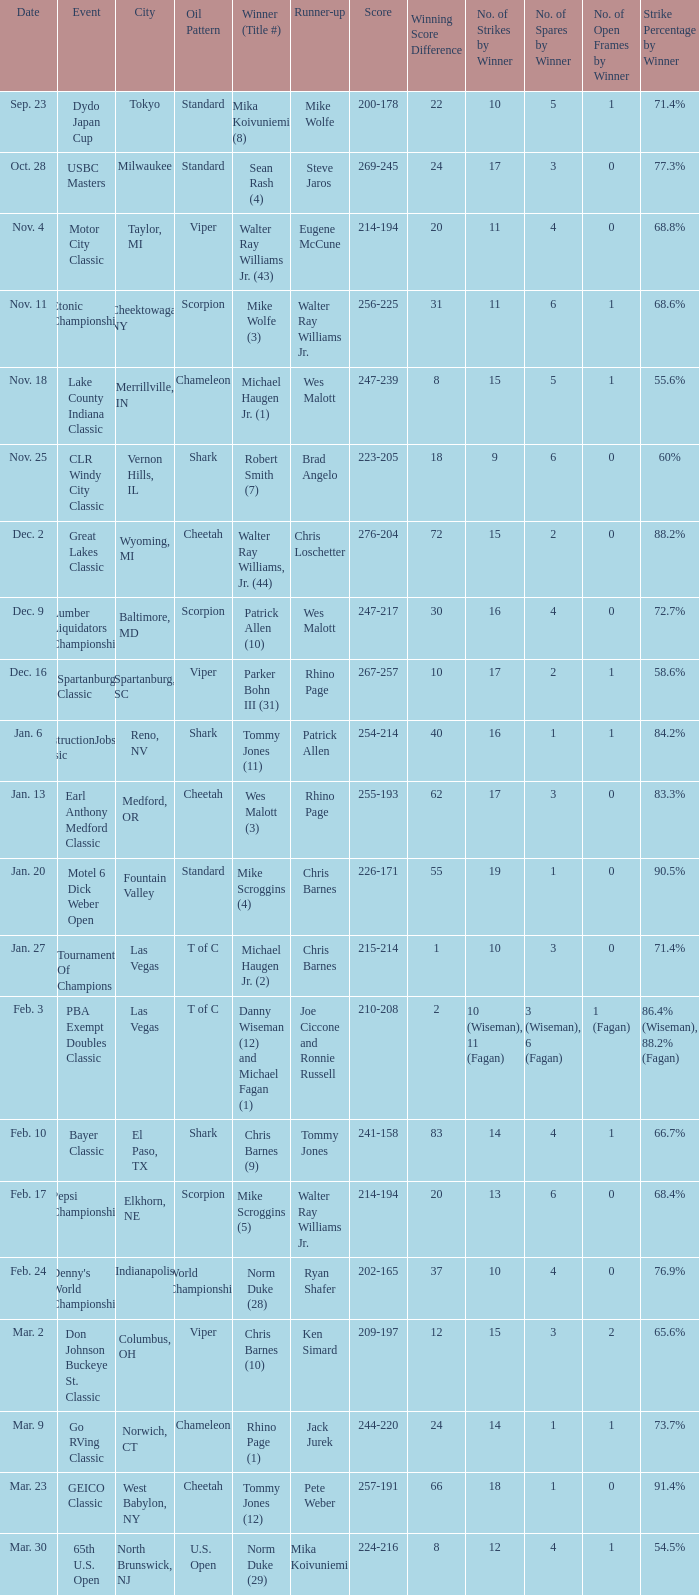Write the full table. {'header': ['Date', 'Event', 'City', 'Oil Pattern', 'Winner (Title #)', 'Runner-up', 'Score', 'Winning Score Difference', 'No. of Strikes by Winner', 'No. of Spares by Winner', 'No. of Open Frames by Winner', 'Strike Percentage by Winner'], 'rows': [['Sep. 23', 'Dydo Japan Cup', 'Tokyo', 'Standard', 'Mika Koivuniemi (8)', 'Mike Wolfe', '200-178', '22', '10', '5', '1', '71.4%'], ['Oct. 28', 'USBC Masters', 'Milwaukee', 'Standard', 'Sean Rash (4)', 'Steve Jaros', '269-245', '24', '17', '3', '0', '77.3%'], ['Nov. 4', 'Motor City Classic', 'Taylor, MI', 'Viper', 'Walter Ray Williams Jr. (43)', 'Eugene McCune', '214-194', '20', '11', '4', '0', '68.8%'], ['Nov. 11', 'Etonic Championship', 'Cheektowaga, NY', 'Scorpion', 'Mike Wolfe (3)', 'Walter Ray Williams Jr.', '256-225', '31', '11', '6', '1', '68.6%'], ['Nov. 18', 'Lake County Indiana Classic', 'Merrillville, IN', 'Chameleon', 'Michael Haugen Jr. (1)', 'Wes Malott', '247-239', '8', '15', '5', '1', '55.6%'], ['Nov. 25', 'CLR Windy City Classic', 'Vernon Hills, IL', 'Shark', 'Robert Smith (7)', 'Brad Angelo', '223-205', '18', '9', '6', '0', '60%'], ['Dec. 2', 'Great Lakes Classic', 'Wyoming, MI', 'Cheetah', 'Walter Ray Williams, Jr. (44)', 'Chris Loschetter', '276-204', '72', '15', '2', '0', '88.2%'], ['Dec. 9', 'Lumber Liquidators Championship', 'Baltimore, MD', 'Scorpion', 'Patrick Allen (10)', 'Wes Malott', '247-217', '30', '16', '4', '0', '72.7%'], ['Dec. 16', 'Spartanburg Classic', 'Spartanburg, SC', 'Viper', 'Parker Bohn III (31)', 'Rhino Page', '267-257', '10', '17', '2', '1', '58.6%'], ['Jan. 6', 'ConstructionJobs.com Classic', 'Reno, NV', 'Shark', 'Tommy Jones (11)', 'Patrick Allen', '254-214', '40', '16', '1', '1', '84.2%'], ['Jan. 13', 'Earl Anthony Medford Classic', 'Medford, OR', 'Cheetah', 'Wes Malott (3)', 'Rhino Page', '255-193', '62', '17', '3', '0', '83.3%'], ['Jan. 20', 'Motel 6 Dick Weber Open', 'Fountain Valley', 'Standard', 'Mike Scroggins (4)', 'Chris Barnes', '226-171', '55', '19', '1', '0', '90.5%'], ['Jan. 27', 'Tournament Of Champions', 'Las Vegas', 'T of C', 'Michael Haugen Jr. (2)', 'Chris Barnes', '215-214', '1', '10', '3', '0', '71.4%'], ['Feb. 3', 'PBA Exempt Doubles Classic', 'Las Vegas', 'T of C', 'Danny Wiseman (12) and Michael Fagan (1)', 'Joe Ciccone and Ronnie Russell', '210-208', '2', '10 (Wiseman), 11 (Fagan)', '3 (Wiseman), 6 (Fagan)', '1 (Fagan)', '86.4% (Wiseman), 88.2% (Fagan)'], ['Feb. 10', 'Bayer Classic', 'El Paso, TX', 'Shark', 'Chris Barnes (9)', 'Tommy Jones', '241-158', '83', '14', '4', '1', '66.7%'], ['Feb. 17', 'Pepsi Championship', 'Elkhorn, NE', 'Scorpion', 'Mike Scroggins (5)', 'Walter Ray Williams Jr.', '214-194', '20', '13', '6', '0', '68.4%'], ['Feb. 24', "Denny's World Championship", 'Indianapolis', 'World Championship', 'Norm Duke (28)', 'Ryan Shafer', '202-165', '37', '10', '4', '0', '76.9%'], ['Mar. 2', 'Don Johnson Buckeye St. Classic', 'Columbus, OH', 'Viper', 'Chris Barnes (10)', 'Ken Simard', '209-197', '12', '15', '3', '2', '65.6%'], ['Mar. 9', 'Go RVing Classic', 'Norwich, CT', 'Chameleon', 'Rhino Page (1)', 'Jack Jurek', '244-220', '24', '14', '1', '1', '73.7%'], ['Mar. 23', 'GEICO Classic', 'West Babylon, NY', 'Cheetah', 'Tommy Jones (12)', 'Pete Weber', '257-191', '66', '18', '1', '0', '91.4%'], ['Mar. 30', '65th U.S. Open', 'North Brunswick, NJ', 'U.S. Open', 'Norm Duke (29)', 'Mika Koivuniemi', '224-216', '8', '12', '4', '1', '54.5%']]} Name the Event which has a Winner (Title #) of parker bohn iii (31)? Spartanburg Classic. 